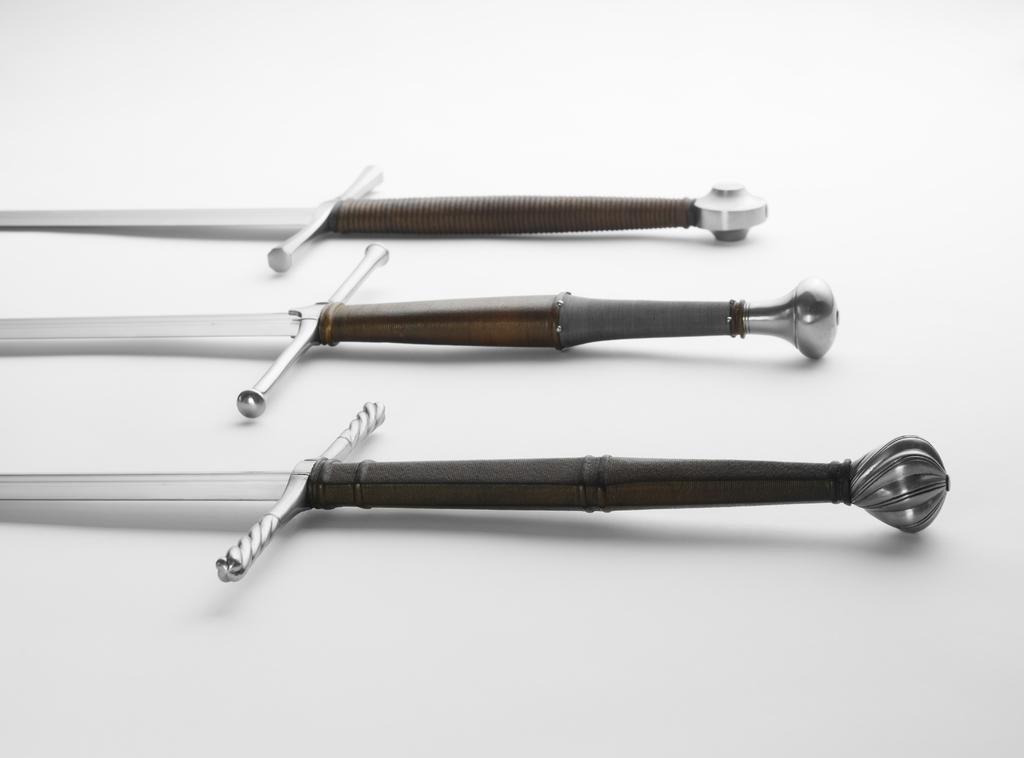What type of objects are present in the image? There are weapons in the image. What colors can be seen on the weapons? The weapons have white, brown, and black colors. What is the color of the surface on which the weapons are placed? The weapons are on a white color surface. How does the memory of the weapons affect the debt in the image? There is no mention of memory or debt in the image, as it only features weapons on a white surface. 